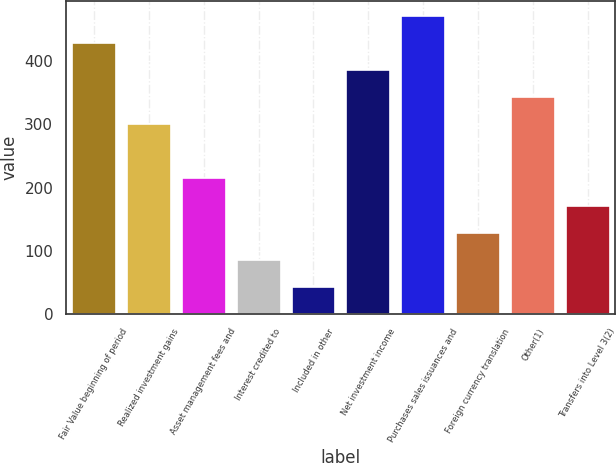Convert chart to OTSL. <chart><loc_0><loc_0><loc_500><loc_500><bar_chart><fcel>Fair Value beginning of period<fcel>Realized investment gains<fcel>Asset management fees and<fcel>Interest credited to<fcel>Included in other<fcel>Net investment income<fcel>Purchases sales issuances and<fcel>Foreign currency translation<fcel>Other(1)<fcel>Transfers into Level 3(2)<nl><fcel>429.02<fcel>300.35<fcel>214.57<fcel>85.9<fcel>43.01<fcel>386.13<fcel>471.91<fcel>128.79<fcel>343.24<fcel>171.68<nl></chart> 